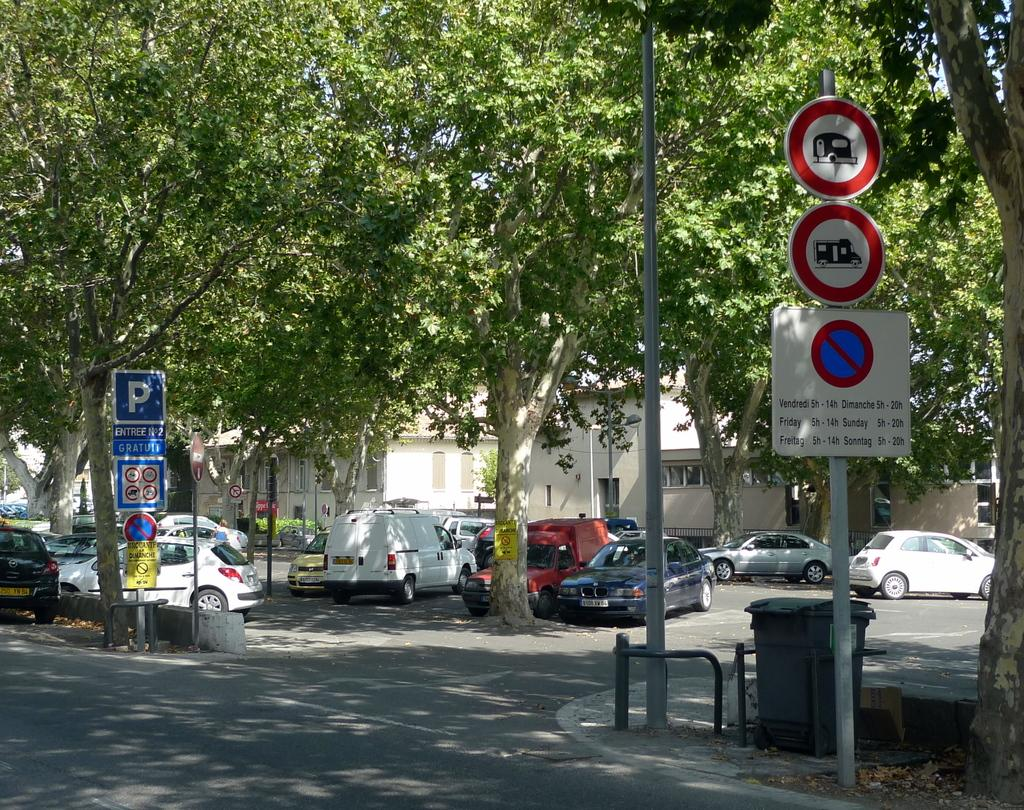<image>
Render a clear and concise summary of the photo. A bus schedule running 5-14 some days and 5-20 on others 